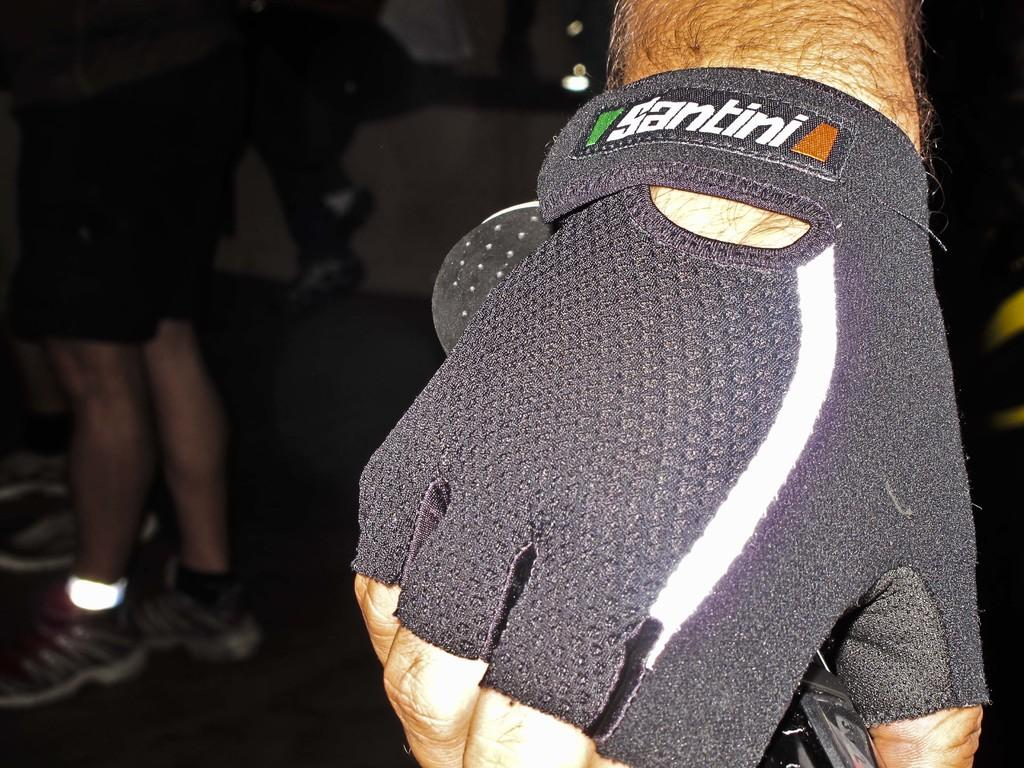What can be seen in the image related to a person's hand? There is a person's hand with a glove in the image. What is the hand holding? The hand is holding an object. What else can be seen in the background of the image? There are legs of people visible in the background of the image. Can you describe the flock of birds flying in the image? There are no birds visible in the image; it only shows a person's hand with a glove, an object being held, and legs of people in the background. 